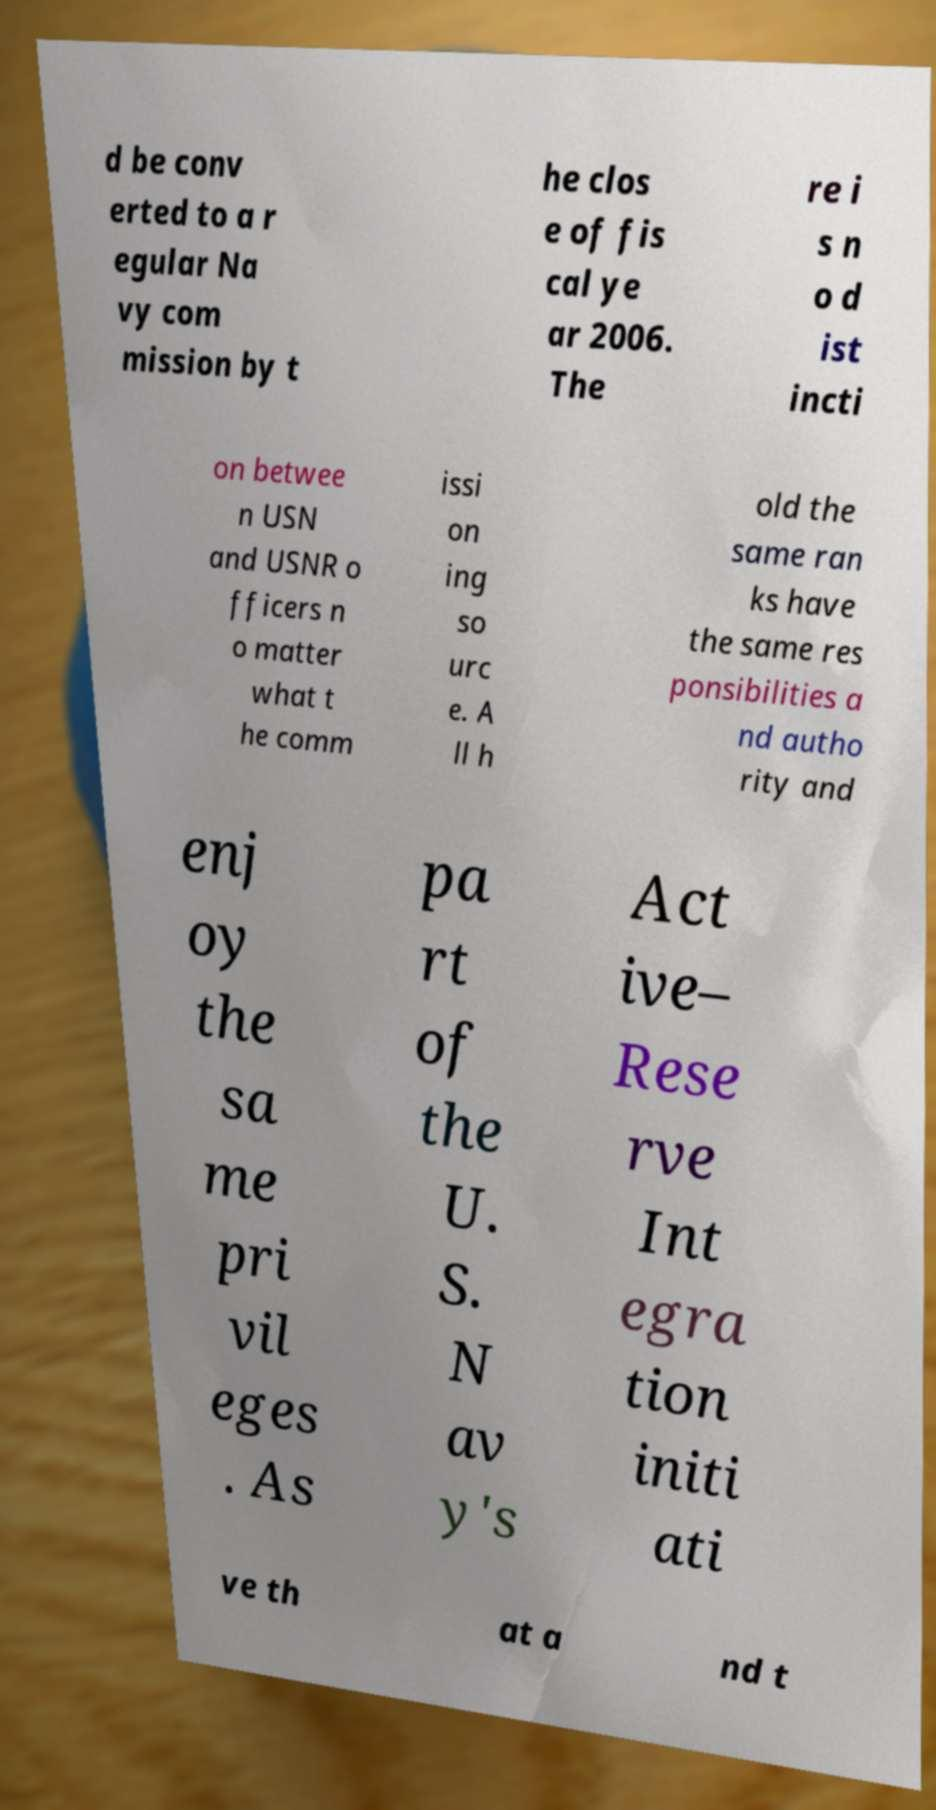Please read and relay the text visible in this image. What does it say? d be conv erted to a r egular Na vy com mission by t he clos e of fis cal ye ar 2006. The re i s n o d ist incti on betwee n USN and USNR o fficers n o matter what t he comm issi on ing so urc e. A ll h old the same ran ks have the same res ponsibilities a nd autho rity and enj oy the sa me pri vil eges . As pa rt of the U. S. N av y's Act ive– Rese rve Int egra tion initi ati ve th at a nd t 